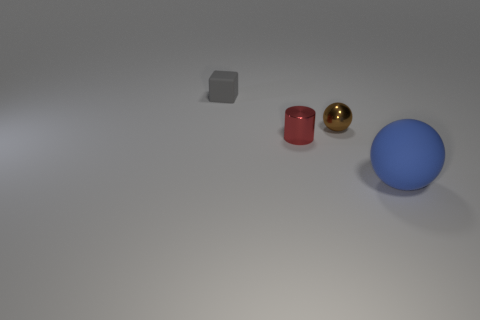Add 3 tiny balls. How many objects exist? 7 Subtract all cylinders. How many objects are left? 3 Subtract 0 brown cylinders. How many objects are left? 4 Subtract all small gray matte objects. Subtract all tiny shiny balls. How many objects are left? 2 Add 4 tiny shiny cylinders. How many tiny shiny cylinders are left? 5 Add 1 purple metallic cubes. How many purple metallic cubes exist? 1 